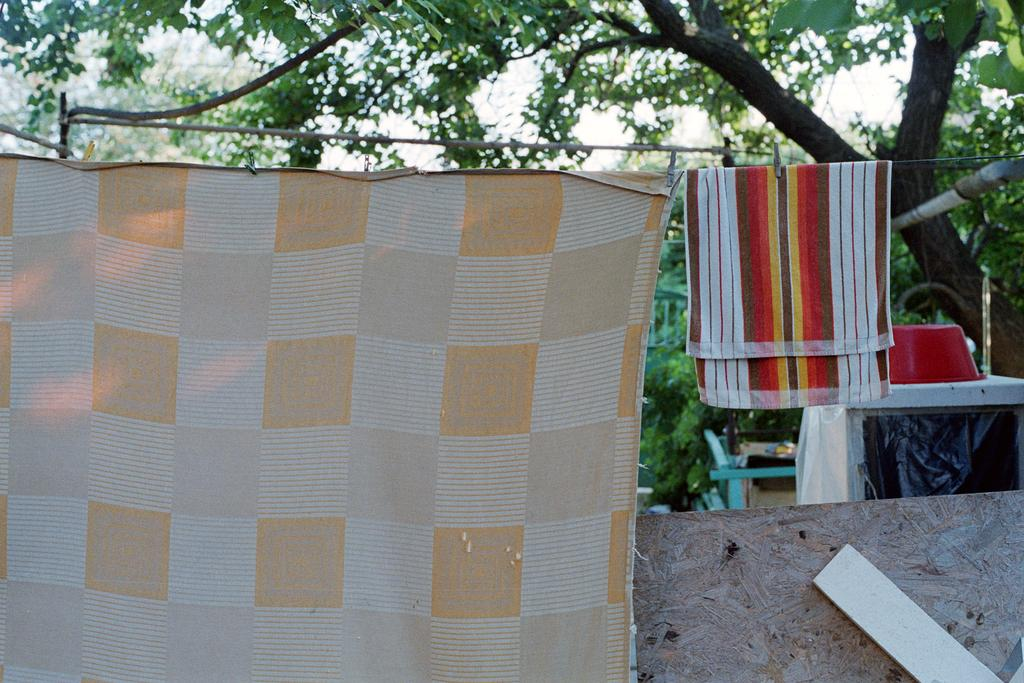What is hanging on a rope in the image? There is a bed sheet and a napkin hanging on a rope in the image. What is present on the table in the image? There is a tub on the table in the image. What can be seen in the background of the image? There are trees in the background of the image. What type of engine is visible in the image? There is no engine present in the image. Is there a steel structure visible in the image? There is no steel structure present in the image. 